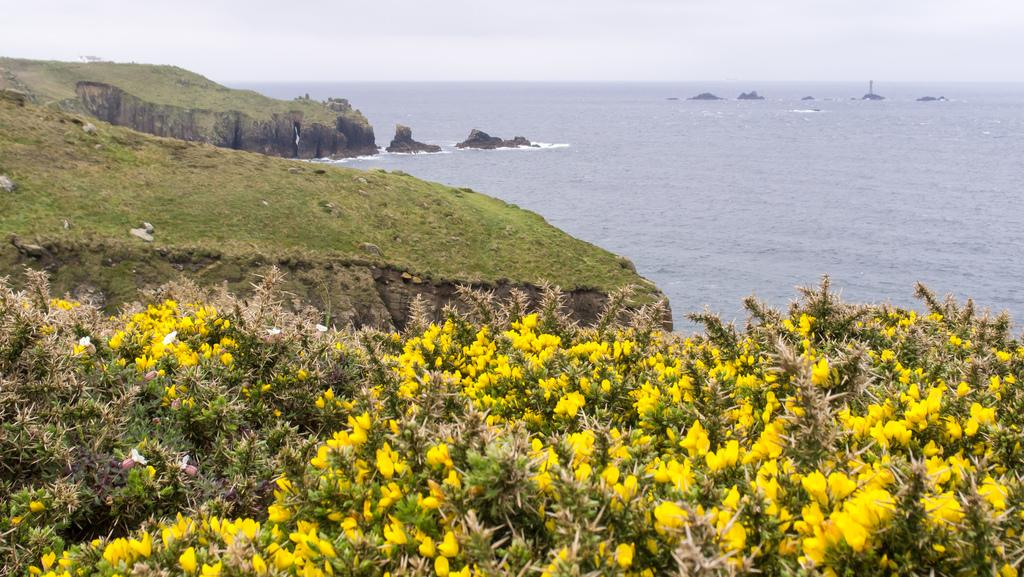What type of vegetation is at the bottom of the image? There are flower plants at the bottom of the image. What can be seen in the middle of the image? There is a surface of water in the middle of the image. What is visible in the background of the image? The sky is visible in the background of the image. What type of branch can be seen in the image? There is no branch present in the image. Is there a judge visible in the image? No, there is no judge present in the image. 